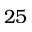Convert formula to latex. <formula><loc_0><loc_0><loc_500><loc_500>2 5</formula> 